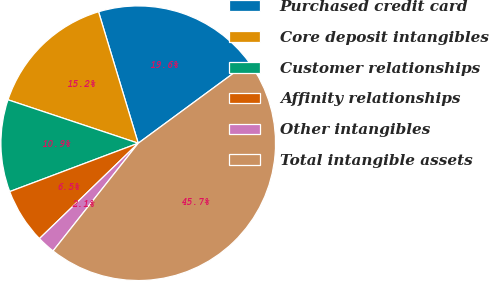<chart> <loc_0><loc_0><loc_500><loc_500><pie_chart><fcel>Purchased credit card<fcel>Core deposit intangibles<fcel>Customer relationships<fcel>Affinity relationships<fcel>Other intangibles<fcel>Total intangible assets<nl><fcel>19.57%<fcel>15.21%<fcel>10.85%<fcel>6.49%<fcel>2.13%<fcel>45.73%<nl></chart> 